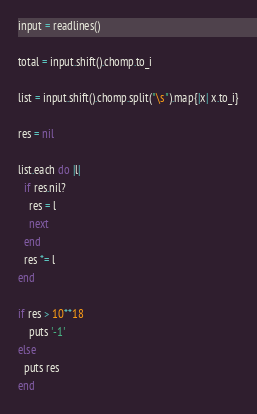Convert code to text. <code><loc_0><loc_0><loc_500><loc_500><_Ruby_>input = readlines()

total = input.shift().chomp.to_i

list = input.shift().chomp.split("\s").map{|x| x.to_i}

res = nil

list.each do |l|
  if res.nil?
    res = l
    next
  end
  res *= l
end

if res > 10**18
    puts '-1'
else
  puts res
end</code> 